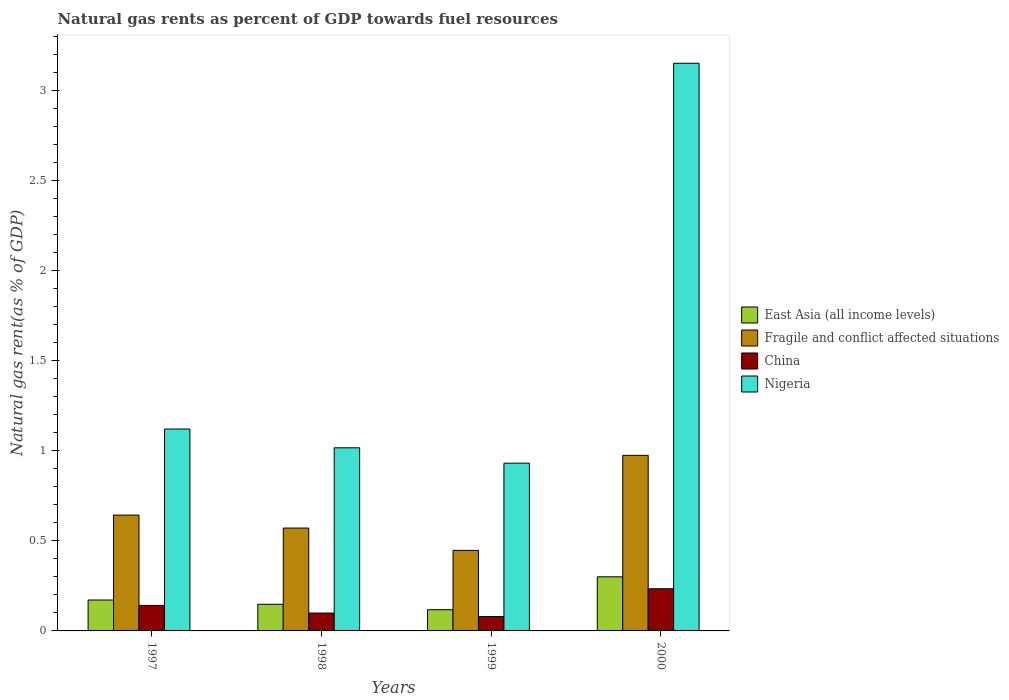Are the number of bars per tick equal to the number of legend labels?
Offer a very short reply. Yes. What is the label of the 4th group of bars from the left?
Your answer should be compact. 2000. In how many cases, is the number of bars for a given year not equal to the number of legend labels?
Keep it short and to the point. 0. What is the natural gas rent in China in 2000?
Your answer should be very brief. 0.23. Across all years, what is the maximum natural gas rent in Nigeria?
Your answer should be compact. 3.15. Across all years, what is the minimum natural gas rent in East Asia (all income levels)?
Provide a short and direct response. 0.12. What is the total natural gas rent in Fragile and conflict affected situations in the graph?
Provide a short and direct response. 2.64. What is the difference between the natural gas rent in Nigeria in 1997 and that in 1999?
Your answer should be very brief. 0.19. What is the difference between the natural gas rent in China in 2000 and the natural gas rent in East Asia (all income levels) in 1999?
Provide a short and direct response. 0.12. What is the average natural gas rent in Nigeria per year?
Make the answer very short. 1.56. In the year 1998, what is the difference between the natural gas rent in Nigeria and natural gas rent in Fragile and conflict affected situations?
Your answer should be very brief. 0.45. What is the ratio of the natural gas rent in Nigeria in 1998 to that in 2000?
Your answer should be compact. 0.32. What is the difference between the highest and the second highest natural gas rent in Fragile and conflict affected situations?
Provide a short and direct response. 0.33. What is the difference between the highest and the lowest natural gas rent in China?
Keep it short and to the point. 0.15. In how many years, is the natural gas rent in China greater than the average natural gas rent in China taken over all years?
Provide a short and direct response. 2. Is the sum of the natural gas rent in China in 1997 and 2000 greater than the maximum natural gas rent in Fragile and conflict affected situations across all years?
Give a very brief answer. No. Is it the case that in every year, the sum of the natural gas rent in Nigeria and natural gas rent in China is greater than the sum of natural gas rent in Fragile and conflict affected situations and natural gas rent in East Asia (all income levels)?
Offer a terse response. No. What does the 1st bar from the left in 2000 represents?
Offer a terse response. East Asia (all income levels). What does the 3rd bar from the right in 1999 represents?
Your response must be concise. Fragile and conflict affected situations. Is it the case that in every year, the sum of the natural gas rent in East Asia (all income levels) and natural gas rent in Fragile and conflict affected situations is greater than the natural gas rent in China?
Offer a very short reply. Yes. How many bars are there?
Your answer should be very brief. 16. What is the difference between two consecutive major ticks on the Y-axis?
Keep it short and to the point. 0.5. Are the values on the major ticks of Y-axis written in scientific E-notation?
Offer a very short reply. No. Does the graph contain any zero values?
Ensure brevity in your answer.  No. Does the graph contain grids?
Your answer should be compact. No. Where does the legend appear in the graph?
Give a very brief answer. Center right. How are the legend labels stacked?
Your answer should be compact. Vertical. What is the title of the graph?
Your answer should be compact. Natural gas rents as percent of GDP towards fuel resources. What is the label or title of the X-axis?
Ensure brevity in your answer.  Years. What is the label or title of the Y-axis?
Ensure brevity in your answer.  Natural gas rent(as % of GDP). What is the Natural gas rent(as % of GDP) of East Asia (all income levels) in 1997?
Ensure brevity in your answer.  0.17. What is the Natural gas rent(as % of GDP) in Fragile and conflict affected situations in 1997?
Offer a terse response. 0.64. What is the Natural gas rent(as % of GDP) in China in 1997?
Offer a terse response. 0.14. What is the Natural gas rent(as % of GDP) of Nigeria in 1997?
Make the answer very short. 1.12. What is the Natural gas rent(as % of GDP) of East Asia (all income levels) in 1998?
Offer a terse response. 0.15. What is the Natural gas rent(as % of GDP) in Fragile and conflict affected situations in 1998?
Ensure brevity in your answer.  0.57. What is the Natural gas rent(as % of GDP) of China in 1998?
Give a very brief answer. 0.1. What is the Natural gas rent(as % of GDP) in Nigeria in 1998?
Make the answer very short. 1.02. What is the Natural gas rent(as % of GDP) in East Asia (all income levels) in 1999?
Provide a short and direct response. 0.12. What is the Natural gas rent(as % of GDP) of Fragile and conflict affected situations in 1999?
Your answer should be compact. 0.45. What is the Natural gas rent(as % of GDP) in China in 1999?
Offer a terse response. 0.08. What is the Natural gas rent(as % of GDP) in Nigeria in 1999?
Make the answer very short. 0.93. What is the Natural gas rent(as % of GDP) in East Asia (all income levels) in 2000?
Make the answer very short. 0.3. What is the Natural gas rent(as % of GDP) in Fragile and conflict affected situations in 2000?
Offer a terse response. 0.97. What is the Natural gas rent(as % of GDP) in China in 2000?
Offer a very short reply. 0.23. What is the Natural gas rent(as % of GDP) in Nigeria in 2000?
Provide a short and direct response. 3.15. Across all years, what is the maximum Natural gas rent(as % of GDP) of East Asia (all income levels)?
Offer a terse response. 0.3. Across all years, what is the maximum Natural gas rent(as % of GDP) of Fragile and conflict affected situations?
Your answer should be very brief. 0.97. Across all years, what is the maximum Natural gas rent(as % of GDP) of China?
Your answer should be compact. 0.23. Across all years, what is the maximum Natural gas rent(as % of GDP) of Nigeria?
Ensure brevity in your answer.  3.15. Across all years, what is the minimum Natural gas rent(as % of GDP) of East Asia (all income levels)?
Give a very brief answer. 0.12. Across all years, what is the minimum Natural gas rent(as % of GDP) in Fragile and conflict affected situations?
Keep it short and to the point. 0.45. Across all years, what is the minimum Natural gas rent(as % of GDP) of China?
Your response must be concise. 0.08. Across all years, what is the minimum Natural gas rent(as % of GDP) in Nigeria?
Offer a terse response. 0.93. What is the total Natural gas rent(as % of GDP) of East Asia (all income levels) in the graph?
Offer a terse response. 0.74. What is the total Natural gas rent(as % of GDP) in Fragile and conflict affected situations in the graph?
Offer a very short reply. 2.64. What is the total Natural gas rent(as % of GDP) of China in the graph?
Give a very brief answer. 0.55. What is the total Natural gas rent(as % of GDP) of Nigeria in the graph?
Keep it short and to the point. 6.22. What is the difference between the Natural gas rent(as % of GDP) of East Asia (all income levels) in 1997 and that in 1998?
Provide a succinct answer. 0.02. What is the difference between the Natural gas rent(as % of GDP) of Fragile and conflict affected situations in 1997 and that in 1998?
Give a very brief answer. 0.07. What is the difference between the Natural gas rent(as % of GDP) of China in 1997 and that in 1998?
Provide a short and direct response. 0.04. What is the difference between the Natural gas rent(as % of GDP) in Nigeria in 1997 and that in 1998?
Provide a succinct answer. 0.1. What is the difference between the Natural gas rent(as % of GDP) in East Asia (all income levels) in 1997 and that in 1999?
Your answer should be very brief. 0.05. What is the difference between the Natural gas rent(as % of GDP) in Fragile and conflict affected situations in 1997 and that in 1999?
Your answer should be very brief. 0.2. What is the difference between the Natural gas rent(as % of GDP) of China in 1997 and that in 1999?
Offer a terse response. 0.06. What is the difference between the Natural gas rent(as % of GDP) of Nigeria in 1997 and that in 1999?
Make the answer very short. 0.19. What is the difference between the Natural gas rent(as % of GDP) of East Asia (all income levels) in 1997 and that in 2000?
Offer a terse response. -0.13. What is the difference between the Natural gas rent(as % of GDP) of Fragile and conflict affected situations in 1997 and that in 2000?
Keep it short and to the point. -0.33. What is the difference between the Natural gas rent(as % of GDP) of China in 1997 and that in 2000?
Your answer should be compact. -0.09. What is the difference between the Natural gas rent(as % of GDP) in Nigeria in 1997 and that in 2000?
Make the answer very short. -2.03. What is the difference between the Natural gas rent(as % of GDP) in Fragile and conflict affected situations in 1998 and that in 1999?
Provide a short and direct response. 0.12. What is the difference between the Natural gas rent(as % of GDP) of China in 1998 and that in 1999?
Your answer should be compact. 0.02. What is the difference between the Natural gas rent(as % of GDP) in Nigeria in 1998 and that in 1999?
Your answer should be very brief. 0.09. What is the difference between the Natural gas rent(as % of GDP) in East Asia (all income levels) in 1998 and that in 2000?
Your answer should be compact. -0.15. What is the difference between the Natural gas rent(as % of GDP) of Fragile and conflict affected situations in 1998 and that in 2000?
Your response must be concise. -0.4. What is the difference between the Natural gas rent(as % of GDP) in China in 1998 and that in 2000?
Offer a very short reply. -0.13. What is the difference between the Natural gas rent(as % of GDP) in Nigeria in 1998 and that in 2000?
Give a very brief answer. -2.14. What is the difference between the Natural gas rent(as % of GDP) in East Asia (all income levels) in 1999 and that in 2000?
Offer a terse response. -0.18. What is the difference between the Natural gas rent(as % of GDP) of Fragile and conflict affected situations in 1999 and that in 2000?
Make the answer very short. -0.53. What is the difference between the Natural gas rent(as % of GDP) of China in 1999 and that in 2000?
Keep it short and to the point. -0.15. What is the difference between the Natural gas rent(as % of GDP) in Nigeria in 1999 and that in 2000?
Your answer should be compact. -2.22. What is the difference between the Natural gas rent(as % of GDP) of East Asia (all income levels) in 1997 and the Natural gas rent(as % of GDP) of Fragile and conflict affected situations in 1998?
Make the answer very short. -0.4. What is the difference between the Natural gas rent(as % of GDP) in East Asia (all income levels) in 1997 and the Natural gas rent(as % of GDP) in China in 1998?
Ensure brevity in your answer.  0.07. What is the difference between the Natural gas rent(as % of GDP) of East Asia (all income levels) in 1997 and the Natural gas rent(as % of GDP) of Nigeria in 1998?
Provide a short and direct response. -0.85. What is the difference between the Natural gas rent(as % of GDP) of Fragile and conflict affected situations in 1997 and the Natural gas rent(as % of GDP) of China in 1998?
Your answer should be compact. 0.54. What is the difference between the Natural gas rent(as % of GDP) of Fragile and conflict affected situations in 1997 and the Natural gas rent(as % of GDP) of Nigeria in 1998?
Offer a very short reply. -0.37. What is the difference between the Natural gas rent(as % of GDP) in China in 1997 and the Natural gas rent(as % of GDP) in Nigeria in 1998?
Ensure brevity in your answer.  -0.88. What is the difference between the Natural gas rent(as % of GDP) of East Asia (all income levels) in 1997 and the Natural gas rent(as % of GDP) of Fragile and conflict affected situations in 1999?
Your response must be concise. -0.28. What is the difference between the Natural gas rent(as % of GDP) of East Asia (all income levels) in 1997 and the Natural gas rent(as % of GDP) of China in 1999?
Keep it short and to the point. 0.09. What is the difference between the Natural gas rent(as % of GDP) in East Asia (all income levels) in 1997 and the Natural gas rent(as % of GDP) in Nigeria in 1999?
Keep it short and to the point. -0.76. What is the difference between the Natural gas rent(as % of GDP) of Fragile and conflict affected situations in 1997 and the Natural gas rent(as % of GDP) of China in 1999?
Your response must be concise. 0.56. What is the difference between the Natural gas rent(as % of GDP) in Fragile and conflict affected situations in 1997 and the Natural gas rent(as % of GDP) in Nigeria in 1999?
Your answer should be very brief. -0.29. What is the difference between the Natural gas rent(as % of GDP) of China in 1997 and the Natural gas rent(as % of GDP) of Nigeria in 1999?
Offer a terse response. -0.79. What is the difference between the Natural gas rent(as % of GDP) in East Asia (all income levels) in 1997 and the Natural gas rent(as % of GDP) in Fragile and conflict affected situations in 2000?
Keep it short and to the point. -0.8. What is the difference between the Natural gas rent(as % of GDP) in East Asia (all income levels) in 1997 and the Natural gas rent(as % of GDP) in China in 2000?
Ensure brevity in your answer.  -0.06. What is the difference between the Natural gas rent(as % of GDP) in East Asia (all income levels) in 1997 and the Natural gas rent(as % of GDP) in Nigeria in 2000?
Provide a short and direct response. -2.98. What is the difference between the Natural gas rent(as % of GDP) of Fragile and conflict affected situations in 1997 and the Natural gas rent(as % of GDP) of China in 2000?
Keep it short and to the point. 0.41. What is the difference between the Natural gas rent(as % of GDP) in Fragile and conflict affected situations in 1997 and the Natural gas rent(as % of GDP) in Nigeria in 2000?
Offer a terse response. -2.51. What is the difference between the Natural gas rent(as % of GDP) of China in 1997 and the Natural gas rent(as % of GDP) of Nigeria in 2000?
Make the answer very short. -3.01. What is the difference between the Natural gas rent(as % of GDP) in East Asia (all income levels) in 1998 and the Natural gas rent(as % of GDP) in Fragile and conflict affected situations in 1999?
Your response must be concise. -0.3. What is the difference between the Natural gas rent(as % of GDP) of East Asia (all income levels) in 1998 and the Natural gas rent(as % of GDP) of China in 1999?
Your answer should be very brief. 0.07. What is the difference between the Natural gas rent(as % of GDP) of East Asia (all income levels) in 1998 and the Natural gas rent(as % of GDP) of Nigeria in 1999?
Keep it short and to the point. -0.78. What is the difference between the Natural gas rent(as % of GDP) of Fragile and conflict affected situations in 1998 and the Natural gas rent(as % of GDP) of China in 1999?
Offer a terse response. 0.49. What is the difference between the Natural gas rent(as % of GDP) in Fragile and conflict affected situations in 1998 and the Natural gas rent(as % of GDP) in Nigeria in 1999?
Offer a very short reply. -0.36. What is the difference between the Natural gas rent(as % of GDP) of China in 1998 and the Natural gas rent(as % of GDP) of Nigeria in 1999?
Make the answer very short. -0.83. What is the difference between the Natural gas rent(as % of GDP) in East Asia (all income levels) in 1998 and the Natural gas rent(as % of GDP) in Fragile and conflict affected situations in 2000?
Your answer should be compact. -0.83. What is the difference between the Natural gas rent(as % of GDP) of East Asia (all income levels) in 1998 and the Natural gas rent(as % of GDP) of China in 2000?
Your answer should be compact. -0.09. What is the difference between the Natural gas rent(as % of GDP) in East Asia (all income levels) in 1998 and the Natural gas rent(as % of GDP) in Nigeria in 2000?
Ensure brevity in your answer.  -3. What is the difference between the Natural gas rent(as % of GDP) in Fragile and conflict affected situations in 1998 and the Natural gas rent(as % of GDP) in China in 2000?
Keep it short and to the point. 0.34. What is the difference between the Natural gas rent(as % of GDP) in Fragile and conflict affected situations in 1998 and the Natural gas rent(as % of GDP) in Nigeria in 2000?
Provide a succinct answer. -2.58. What is the difference between the Natural gas rent(as % of GDP) of China in 1998 and the Natural gas rent(as % of GDP) of Nigeria in 2000?
Give a very brief answer. -3.05. What is the difference between the Natural gas rent(as % of GDP) of East Asia (all income levels) in 1999 and the Natural gas rent(as % of GDP) of Fragile and conflict affected situations in 2000?
Give a very brief answer. -0.86. What is the difference between the Natural gas rent(as % of GDP) in East Asia (all income levels) in 1999 and the Natural gas rent(as % of GDP) in China in 2000?
Your response must be concise. -0.12. What is the difference between the Natural gas rent(as % of GDP) in East Asia (all income levels) in 1999 and the Natural gas rent(as % of GDP) in Nigeria in 2000?
Your answer should be compact. -3.03. What is the difference between the Natural gas rent(as % of GDP) of Fragile and conflict affected situations in 1999 and the Natural gas rent(as % of GDP) of China in 2000?
Your response must be concise. 0.21. What is the difference between the Natural gas rent(as % of GDP) of Fragile and conflict affected situations in 1999 and the Natural gas rent(as % of GDP) of Nigeria in 2000?
Offer a terse response. -2.71. What is the difference between the Natural gas rent(as % of GDP) in China in 1999 and the Natural gas rent(as % of GDP) in Nigeria in 2000?
Provide a succinct answer. -3.07. What is the average Natural gas rent(as % of GDP) of East Asia (all income levels) per year?
Give a very brief answer. 0.18. What is the average Natural gas rent(as % of GDP) of Fragile and conflict affected situations per year?
Make the answer very short. 0.66. What is the average Natural gas rent(as % of GDP) of China per year?
Ensure brevity in your answer.  0.14. What is the average Natural gas rent(as % of GDP) of Nigeria per year?
Make the answer very short. 1.56. In the year 1997, what is the difference between the Natural gas rent(as % of GDP) of East Asia (all income levels) and Natural gas rent(as % of GDP) of Fragile and conflict affected situations?
Your answer should be very brief. -0.47. In the year 1997, what is the difference between the Natural gas rent(as % of GDP) in East Asia (all income levels) and Natural gas rent(as % of GDP) in China?
Provide a short and direct response. 0.03. In the year 1997, what is the difference between the Natural gas rent(as % of GDP) in East Asia (all income levels) and Natural gas rent(as % of GDP) in Nigeria?
Give a very brief answer. -0.95. In the year 1997, what is the difference between the Natural gas rent(as % of GDP) in Fragile and conflict affected situations and Natural gas rent(as % of GDP) in China?
Your answer should be compact. 0.5. In the year 1997, what is the difference between the Natural gas rent(as % of GDP) of Fragile and conflict affected situations and Natural gas rent(as % of GDP) of Nigeria?
Offer a terse response. -0.48. In the year 1997, what is the difference between the Natural gas rent(as % of GDP) of China and Natural gas rent(as % of GDP) of Nigeria?
Your answer should be very brief. -0.98. In the year 1998, what is the difference between the Natural gas rent(as % of GDP) of East Asia (all income levels) and Natural gas rent(as % of GDP) of Fragile and conflict affected situations?
Provide a succinct answer. -0.42. In the year 1998, what is the difference between the Natural gas rent(as % of GDP) of East Asia (all income levels) and Natural gas rent(as % of GDP) of China?
Provide a short and direct response. 0.05. In the year 1998, what is the difference between the Natural gas rent(as % of GDP) in East Asia (all income levels) and Natural gas rent(as % of GDP) in Nigeria?
Offer a terse response. -0.87. In the year 1998, what is the difference between the Natural gas rent(as % of GDP) in Fragile and conflict affected situations and Natural gas rent(as % of GDP) in China?
Keep it short and to the point. 0.47. In the year 1998, what is the difference between the Natural gas rent(as % of GDP) of Fragile and conflict affected situations and Natural gas rent(as % of GDP) of Nigeria?
Provide a succinct answer. -0.45. In the year 1998, what is the difference between the Natural gas rent(as % of GDP) of China and Natural gas rent(as % of GDP) of Nigeria?
Provide a short and direct response. -0.92. In the year 1999, what is the difference between the Natural gas rent(as % of GDP) in East Asia (all income levels) and Natural gas rent(as % of GDP) in Fragile and conflict affected situations?
Provide a short and direct response. -0.33. In the year 1999, what is the difference between the Natural gas rent(as % of GDP) in East Asia (all income levels) and Natural gas rent(as % of GDP) in China?
Make the answer very short. 0.04. In the year 1999, what is the difference between the Natural gas rent(as % of GDP) of East Asia (all income levels) and Natural gas rent(as % of GDP) of Nigeria?
Keep it short and to the point. -0.81. In the year 1999, what is the difference between the Natural gas rent(as % of GDP) of Fragile and conflict affected situations and Natural gas rent(as % of GDP) of China?
Give a very brief answer. 0.37. In the year 1999, what is the difference between the Natural gas rent(as % of GDP) of Fragile and conflict affected situations and Natural gas rent(as % of GDP) of Nigeria?
Keep it short and to the point. -0.48. In the year 1999, what is the difference between the Natural gas rent(as % of GDP) in China and Natural gas rent(as % of GDP) in Nigeria?
Offer a terse response. -0.85. In the year 2000, what is the difference between the Natural gas rent(as % of GDP) in East Asia (all income levels) and Natural gas rent(as % of GDP) in Fragile and conflict affected situations?
Your answer should be compact. -0.67. In the year 2000, what is the difference between the Natural gas rent(as % of GDP) in East Asia (all income levels) and Natural gas rent(as % of GDP) in China?
Your answer should be very brief. 0.07. In the year 2000, what is the difference between the Natural gas rent(as % of GDP) in East Asia (all income levels) and Natural gas rent(as % of GDP) in Nigeria?
Ensure brevity in your answer.  -2.85. In the year 2000, what is the difference between the Natural gas rent(as % of GDP) of Fragile and conflict affected situations and Natural gas rent(as % of GDP) of China?
Your answer should be compact. 0.74. In the year 2000, what is the difference between the Natural gas rent(as % of GDP) of Fragile and conflict affected situations and Natural gas rent(as % of GDP) of Nigeria?
Offer a terse response. -2.18. In the year 2000, what is the difference between the Natural gas rent(as % of GDP) of China and Natural gas rent(as % of GDP) of Nigeria?
Offer a terse response. -2.92. What is the ratio of the Natural gas rent(as % of GDP) in East Asia (all income levels) in 1997 to that in 1998?
Your answer should be very brief. 1.16. What is the ratio of the Natural gas rent(as % of GDP) of Fragile and conflict affected situations in 1997 to that in 1998?
Give a very brief answer. 1.13. What is the ratio of the Natural gas rent(as % of GDP) in China in 1997 to that in 1998?
Give a very brief answer. 1.43. What is the ratio of the Natural gas rent(as % of GDP) of Nigeria in 1997 to that in 1998?
Your answer should be very brief. 1.1. What is the ratio of the Natural gas rent(as % of GDP) of East Asia (all income levels) in 1997 to that in 1999?
Your answer should be compact. 1.46. What is the ratio of the Natural gas rent(as % of GDP) in Fragile and conflict affected situations in 1997 to that in 1999?
Offer a terse response. 1.44. What is the ratio of the Natural gas rent(as % of GDP) in China in 1997 to that in 1999?
Make the answer very short. 1.78. What is the ratio of the Natural gas rent(as % of GDP) of Nigeria in 1997 to that in 1999?
Provide a short and direct response. 1.2. What is the ratio of the Natural gas rent(as % of GDP) of East Asia (all income levels) in 1997 to that in 2000?
Your answer should be very brief. 0.57. What is the ratio of the Natural gas rent(as % of GDP) in Fragile and conflict affected situations in 1997 to that in 2000?
Provide a short and direct response. 0.66. What is the ratio of the Natural gas rent(as % of GDP) in China in 1997 to that in 2000?
Your answer should be very brief. 0.6. What is the ratio of the Natural gas rent(as % of GDP) of Nigeria in 1997 to that in 2000?
Offer a terse response. 0.36. What is the ratio of the Natural gas rent(as % of GDP) of East Asia (all income levels) in 1998 to that in 1999?
Provide a short and direct response. 1.25. What is the ratio of the Natural gas rent(as % of GDP) in Fragile and conflict affected situations in 1998 to that in 1999?
Your response must be concise. 1.28. What is the ratio of the Natural gas rent(as % of GDP) in China in 1998 to that in 1999?
Give a very brief answer. 1.24. What is the ratio of the Natural gas rent(as % of GDP) of Nigeria in 1998 to that in 1999?
Offer a terse response. 1.09. What is the ratio of the Natural gas rent(as % of GDP) of East Asia (all income levels) in 1998 to that in 2000?
Your answer should be compact. 0.49. What is the ratio of the Natural gas rent(as % of GDP) of Fragile and conflict affected situations in 1998 to that in 2000?
Provide a short and direct response. 0.59. What is the ratio of the Natural gas rent(as % of GDP) of China in 1998 to that in 2000?
Provide a short and direct response. 0.42. What is the ratio of the Natural gas rent(as % of GDP) in Nigeria in 1998 to that in 2000?
Make the answer very short. 0.32. What is the ratio of the Natural gas rent(as % of GDP) of East Asia (all income levels) in 1999 to that in 2000?
Offer a terse response. 0.39. What is the ratio of the Natural gas rent(as % of GDP) in Fragile and conflict affected situations in 1999 to that in 2000?
Ensure brevity in your answer.  0.46. What is the ratio of the Natural gas rent(as % of GDP) in China in 1999 to that in 2000?
Offer a very short reply. 0.34. What is the ratio of the Natural gas rent(as % of GDP) in Nigeria in 1999 to that in 2000?
Offer a terse response. 0.3. What is the difference between the highest and the second highest Natural gas rent(as % of GDP) in East Asia (all income levels)?
Provide a succinct answer. 0.13. What is the difference between the highest and the second highest Natural gas rent(as % of GDP) in Fragile and conflict affected situations?
Your answer should be very brief. 0.33. What is the difference between the highest and the second highest Natural gas rent(as % of GDP) of China?
Give a very brief answer. 0.09. What is the difference between the highest and the second highest Natural gas rent(as % of GDP) in Nigeria?
Make the answer very short. 2.03. What is the difference between the highest and the lowest Natural gas rent(as % of GDP) of East Asia (all income levels)?
Give a very brief answer. 0.18. What is the difference between the highest and the lowest Natural gas rent(as % of GDP) of Fragile and conflict affected situations?
Your response must be concise. 0.53. What is the difference between the highest and the lowest Natural gas rent(as % of GDP) of China?
Provide a short and direct response. 0.15. What is the difference between the highest and the lowest Natural gas rent(as % of GDP) in Nigeria?
Keep it short and to the point. 2.22. 